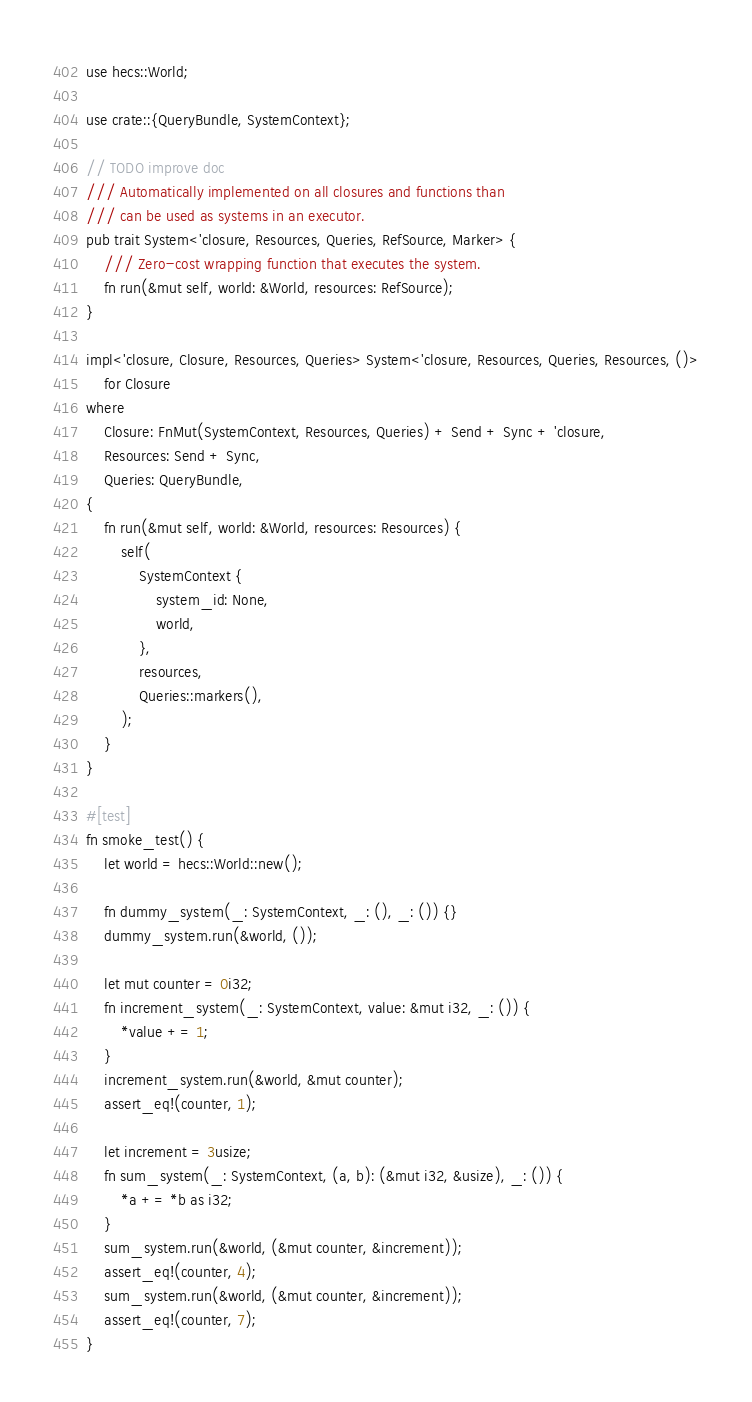Convert code to text. <code><loc_0><loc_0><loc_500><loc_500><_Rust_>use hecs::World;

use crate::{QueryBundle, SystemContext};

// TODO improve doc
/// Automatically implemented on all closures and functions than
/// can be used as systems in an executor.
pub trait System<'closure, Resources, Queries, RefSource, Marker> {
    /// Zero-cost wrapping function that executes the system.
    fn run(&mut self, world: &World, resources: RefSource);
}

impl<'closure, Closure, Resources, Queries> System<'closure, Resources, Queries, Resources, ()>
    for Closure
where
    Closure: FnMut(SystemContext, Resources, Queries) + Send + Sync + 'closure,
    Resources: Send + Sync,
    Queries: QueryBundle,
{
    fn run(&mut self, world: &World, resources: Resources) {
        self(
            SystemContext {
                system_id: None,
                world,
            },
            resources,
            Queries::markers(),
        );
    }
}

#[test]
fn smoke_test() {
    let world = hecs::World::new();

    fn dummy_system(_: SystemContext, _: (), _: ()) {}
    dummy_system.run(&world, ());

    let mut counter = 0i32;
    fn increment_system(_: SystemContext, value: &mut i32, _: ()) {
        *value += 1;
    }
    increment_system.run(&world, &mut counter);
    assert_eq!(counter, 1);

    let increment = 3usize;
    fn sum_system(_: SystemContext, (a, b): (&mut i32, &usize), _: ()) {
        *a += *b as i32;
    }
    sum_system.run(&world, (&mut counter, &increment));
    assert_eq!(counter, 4);
    sum_system.run(&world, (&mut counter, &increment));
    assert_eq!(counter, 7);
}
</code> 